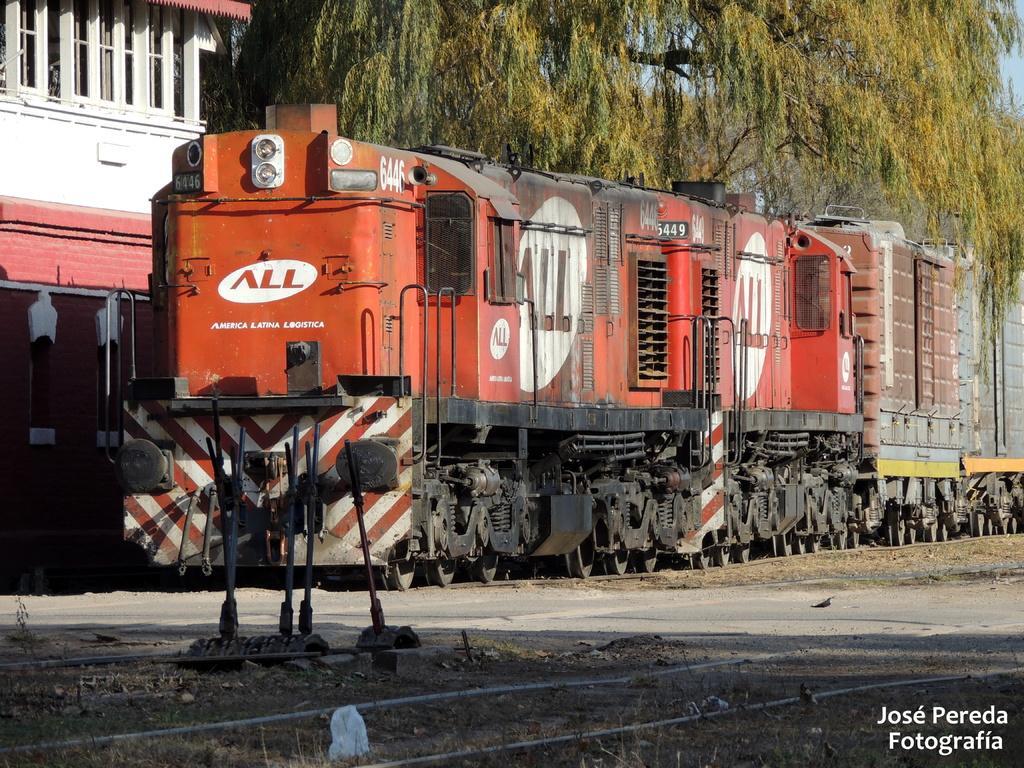How would you summarize this image in a sentence or two? This looks like a train, which is on the railway track. On the left side of the image, I can see a building with the windows. These are the trees with branches and leaves. Here is a railway track. At the bottom right corner of the image, I can see the watermark. 